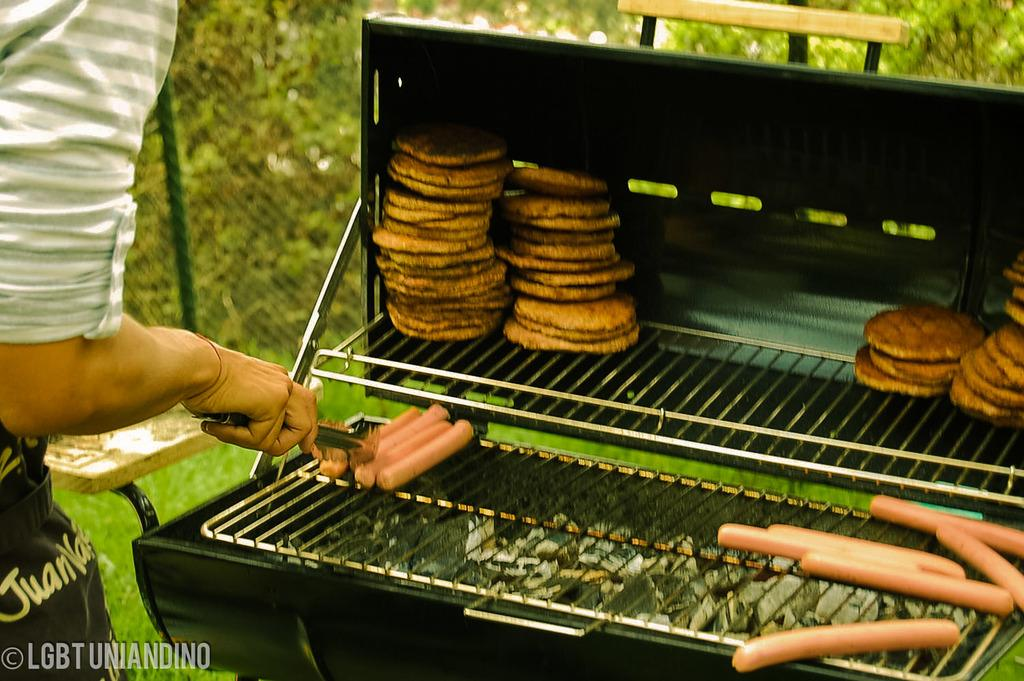<image>
Render a clear and concise summary of the photo. A man with an apron that says Juan on it cooks hot dogs and pancakes on a grill. 